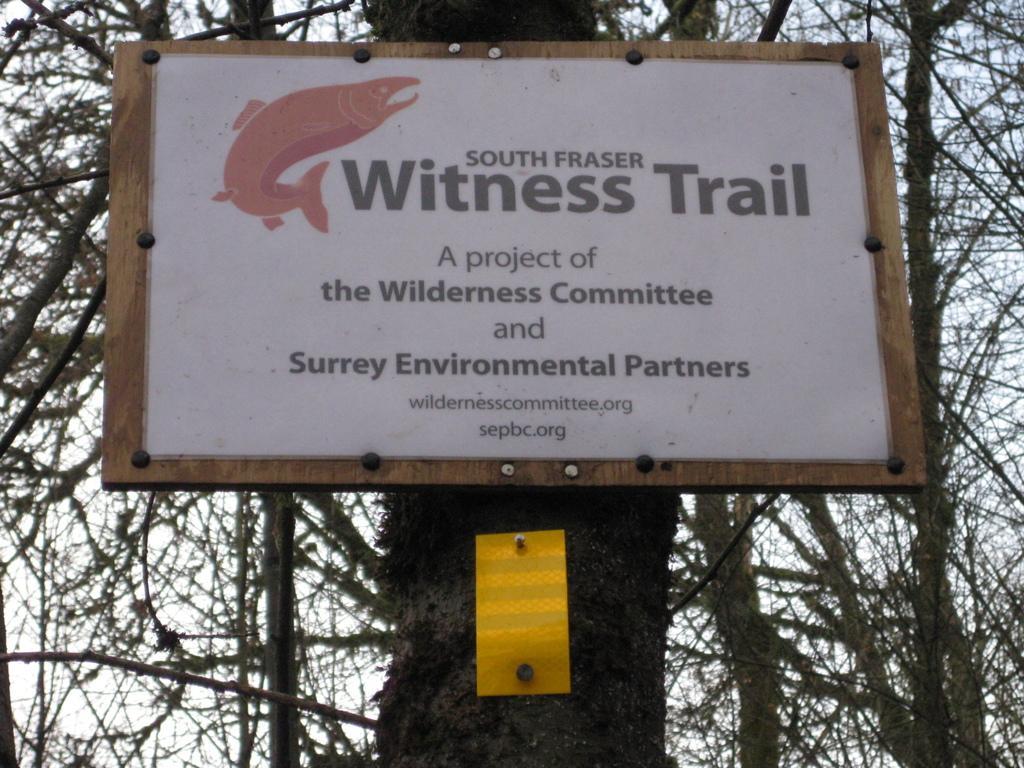Could you give a brief overview of what you see in this image? In this image there is a tree on that tree there is a board, in the background there are trees and sky. 